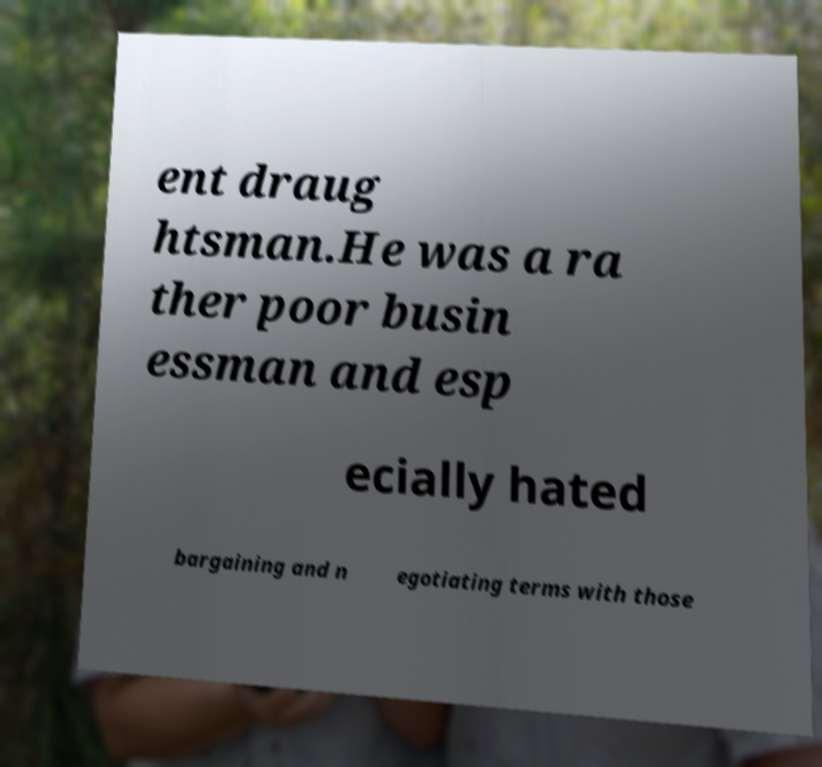Can you read and provide the text displayed in the image?This photo seems to have some interesting text. Can you extract and type it out for me? ent draug htsman.He was a ra ther poor busin essman and esp ecially hated bargaining and n egotiating terms with those 